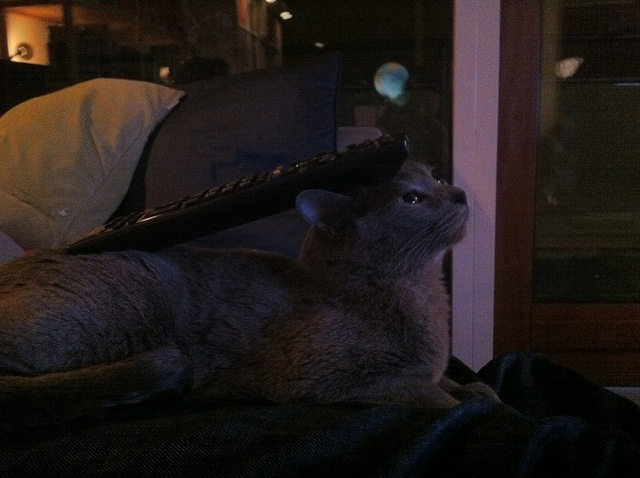Describe the objects in this image and their specific colors. I can see bed in black, maroon, and brown tones, cat in black tones, remote in black, maroon, and gray tones, and couch in black and maroon tones in this image. 